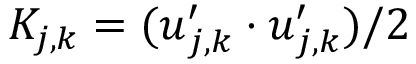Convert formula to latex. <formula><loc_0><loc_0><loc_500><loc_500>K _ { j , k } = ( u _ { j , k } ^ { \prime } \cdot u _ { j , k } ^ { \prime } ) / 2</formula> 